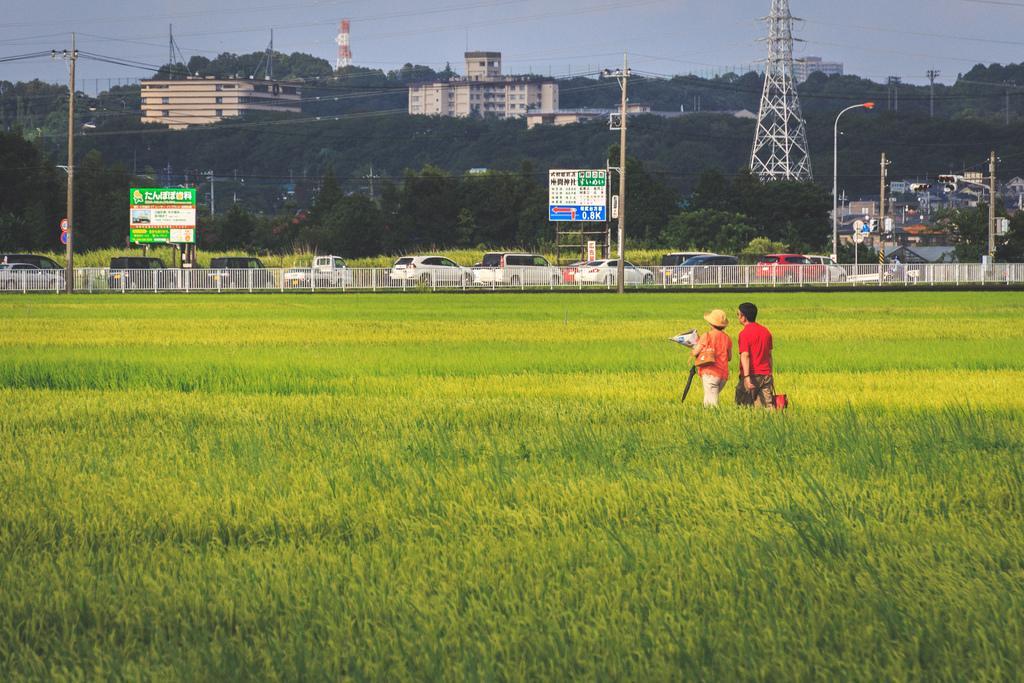Could you give a brief overview of what you see in this image? In this image I can see two people holding something. Back Side I can see few vehicles,trees,boards,poles,light poles,buildings,fencing and wires. In front I can see a green grass. 